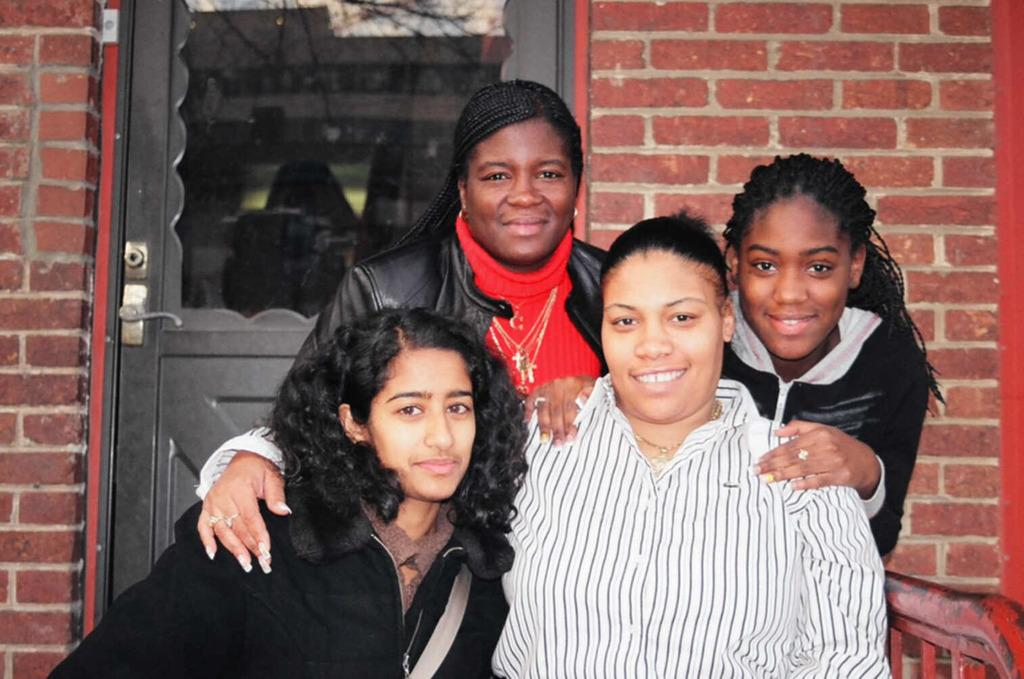Who or what is present in the image? There are people in the image. What is the facial expression of the people in the image? The people in the image are smiling. What can be seen in the background of the image? There is a black color door and a brick wall in the background of the image. What type of grape is being used to make the value of the door in the image? There is no grape or reference to a value of the door in the image. The image features people smiling and a black door with a brick wall in the background. 